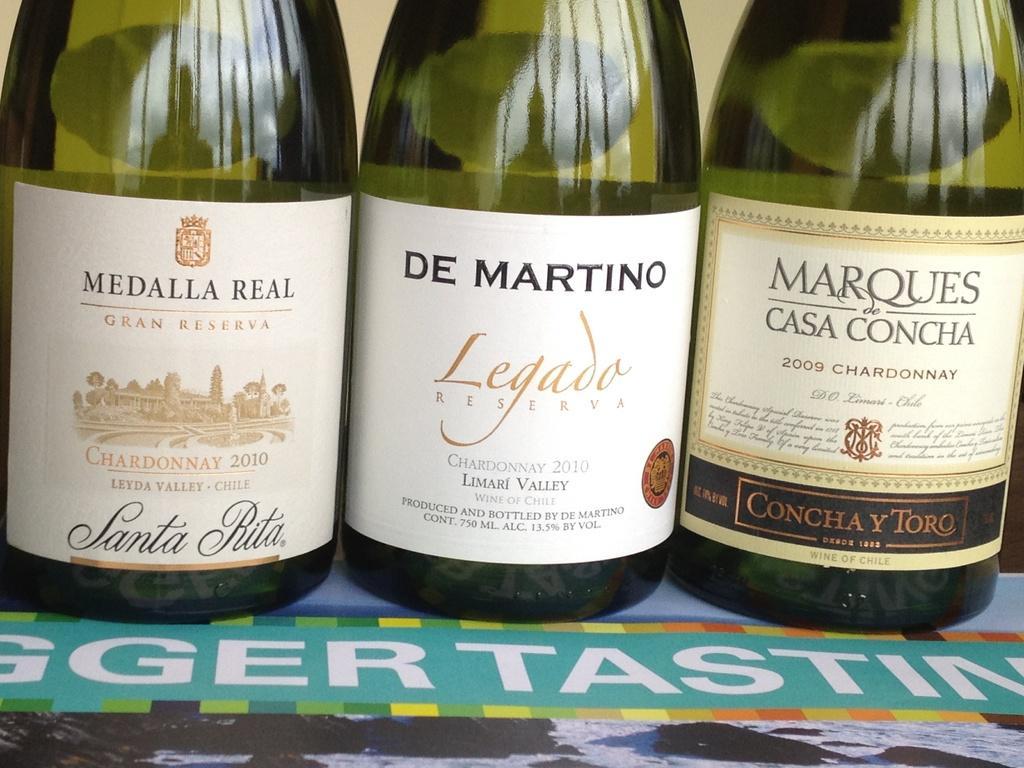In one or two sentences, can you explain what this image depicts? In this picture there are three wine bottle kept on a table and the same wine bottles have different labels pasted on it. In the backdrop there is a wall. 